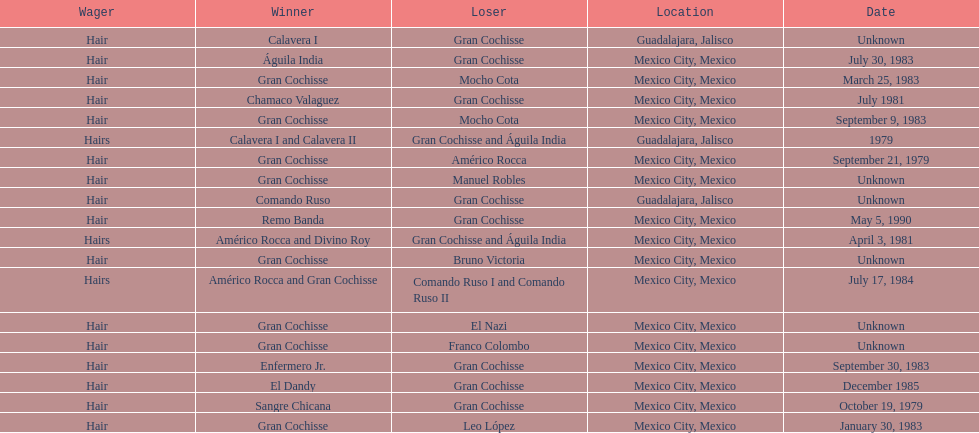What is the frequency of the hair wager? 16. 